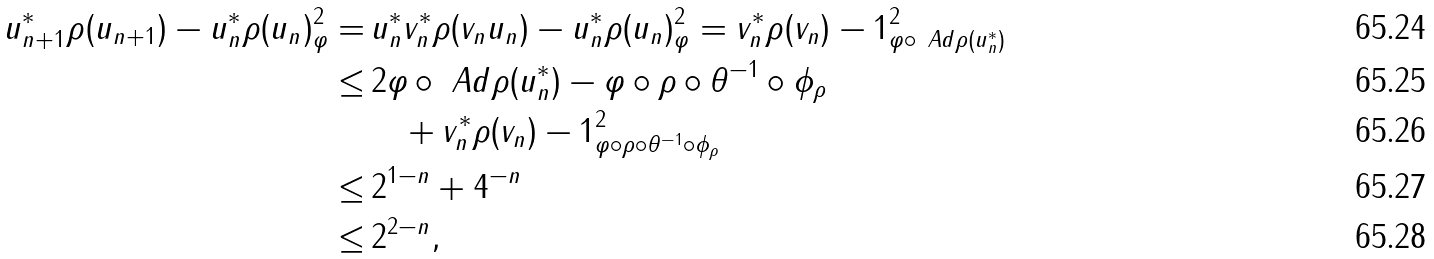<formula> <loc_0><loc_0><loc_500><loc_500>\| u _ { n + 1 } ^ { * } \rho ( u _ { n + 1 } ) - u _ { n } ^ { * } \rho ( u _ { n } ) \| _ { \varphi } ^ { 2 } = & \, \| u _ { n } ^ { * } v _ { n } ^ { * } \rho ( v _ { n } u _ { n } ) - u _ { n } ^ { * } \rho ( u _ { n } ) \| _ { \varphi } ^ { 2 } = \| v _ { n } ^ { * } \rho ( v _ { n } ) - 1 \| _ { \varphi \circ \ A d \rho ( u _ { n } ^ { * } ) } ^ { 2 } \\ \leq & \, 2 \| \varphi \circ \ A d \rho ( u _ { n } ^ { * } ) - \varphi \circ \rho \circ \theta ^ { - 1 } \circ \phi _ { \rho } \| \\ & \quad + \| v _ { n } ^ { * } \rho ( v _ { n } ) - 1 \| _ { \varphi \circ \rho \circ \theta ^ { - 1 } \circ \phi _ { \rho } } ^ { 2 } \\ \leq & \, 2 ^ { 1 - n } + 4 ^ { - n } \\ \leq & \, 2 ^ { 2 - n } ,</formula> 